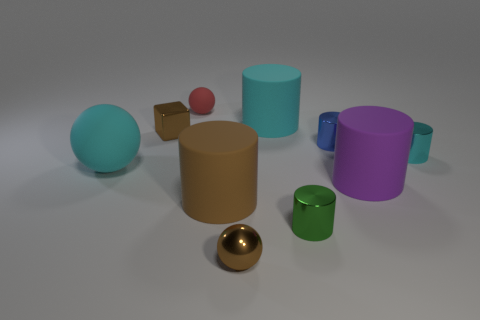Subtract all tiny brown balls. How many balls are left? 2 Subtract all red balls. How many cyan cylinders are left? 2 Subtract all green cylinders. How many cylinders are left? 5 Subtract 1 balls. How many balls are left? 2 Subtract all balls. How many objects are left? 7 Subtract all yellow spheres. Subtract all gray cylinders. How many spheres are left? 3 Subtract all brown balls. Subtract all cyan metal cylinders. How many objects are left? 8 Add 3 large cyan matte balls. How many large cyan matte balls are left? 4 Add 9 big purple cylinders. How many big purple cylinders exist? 10 Subtract 0 blue balls. How many objects are left? 10 